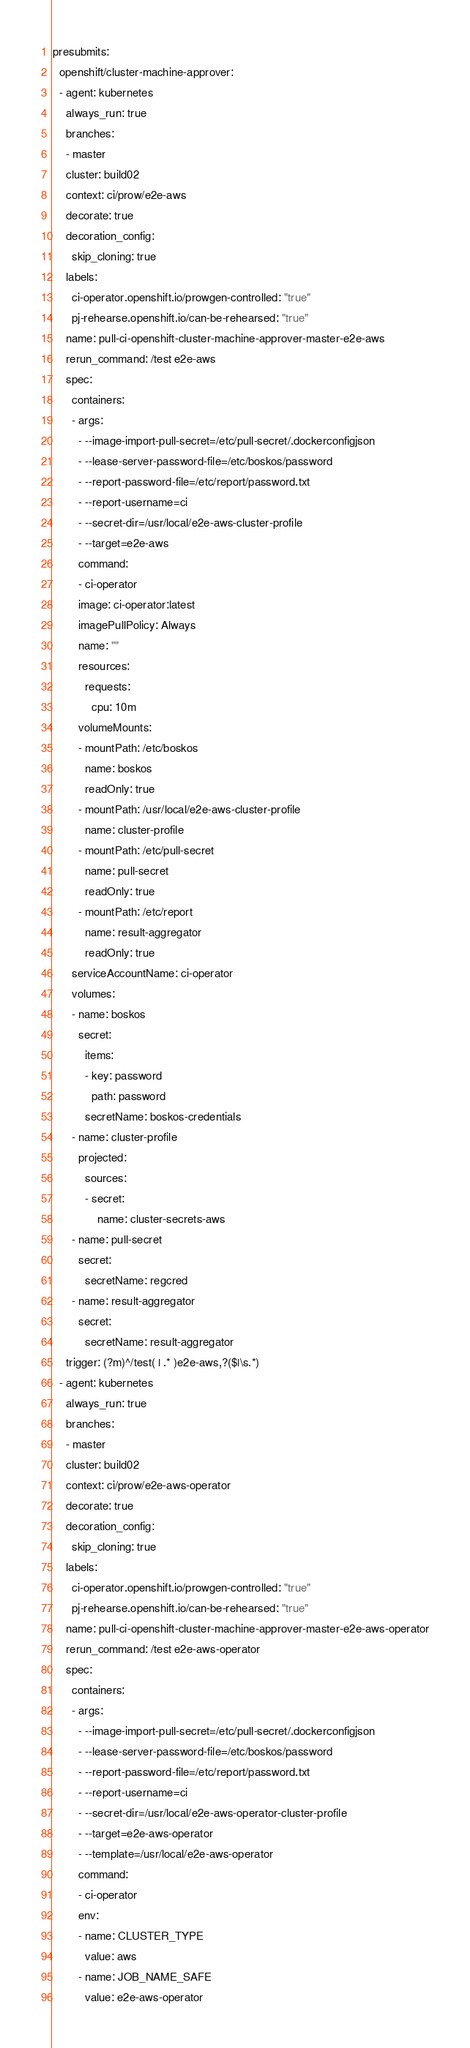<code> <loc_0><loc_0><loc_500><loc_500><_YAML_>presubmits:
  openshift/cluster-machine-approver:
  - agent: kubernetes
    always_run: true
    branches:
    - master
    cluster: build02
    context: ci/prow/e2e-aws
    decorate: true
    decoration_config:
      skip_cloning: true
    labels:
      ci-operator.openshift.io/prowgen-controlled: "true"
      pj-rehearse.openshift.io/can-be-rehearsed: "true"
    name: pull-ci-openshift-cluster-machine-approver-master-e2e-aws
    rerun_command: /test e2e-aws
    spec:
      containers:
      - args:
        - --image-import-pull-secret=/etc/pull-secret/.dockerconfigjson
        - --lease-server-password-file=/etc/boskos/password
        - --report-password-file=/etc/report/password.txt
        - --report-username=ci
        - --secret-dir=/usr/local/e2e-aws-cluster-profile
        - --target=e2e-aws
        command:
        - ci-operator
        image: ci-operator:latest
        imagePullPolicy: Always
        name: ""
        resources:
          requests:
            cpu: 10m
        volumeMounts:
        - mountPath: /etc/boskos
          name: boskos
          readOnly: true
        - mountPath: /usr/local/e2e-aws-cluster-profile
          name: cluster-profile
        - mountPath: /etc/pull-secret
          name: pull-secret
          readOnly: true
        - mountPath: /etc/report
          name: result-aggregator
          readOnly: true
      serviceAccountName: ci-operator
      volumes:
      - name: boskos
        secret:
          items:
          - key: password
            path: password
          secretName: boskos-credentials
      - name: cluster-profile
        projected:
          sources:
          - secret:
              name: cluster-secrets-aws
      - name: pull-secret
        secret:
          secretName: regcred
      - name: result-aggregator
        secret:
          secretName: result-aggregator
    trigger: (?m)^/test( | .* )e2e-aws,?($|\s.*)
  - agent: kubernetes
    always_run: true
    branches:
    - master
    cluster: build02
    context: ci/prow/e2e-aws-operator
    decorate: true
    decoration_config:
      skip_cloning: true
    labels:
      ci-operator.openshift.io/prowgen-controlled: "true"
      pj-rehearse.openshift.io/can-be-rehearsed: "true"
    name: pull-ci-openshift-cluster-machine-approver-master-e2e-aws-operator
    rerun_command: /test e2e-aws-operator
    spec:
      containers:
      - args:
        - --image-import-pull-secret=/etc/pull-secret/.dockerconfigjson
        - --lease-server-password-file=/etc/boskos/password
        - --report-password-file=/etc/report/password.txt
        - --report-username=ci
        - --secret-dir=/usr/local/e2e-aws-operator-cluster-profile
        - --target=e2e-aws-operator
        - --template=/usr/local/e2e-aws-operator
        command:
        - ci-operator
        env:
        - name: CLUSTER_TYPE
          value: aws
        - name: JOB_NAME_SAFE
          value: e2e-aws-operator</code> 